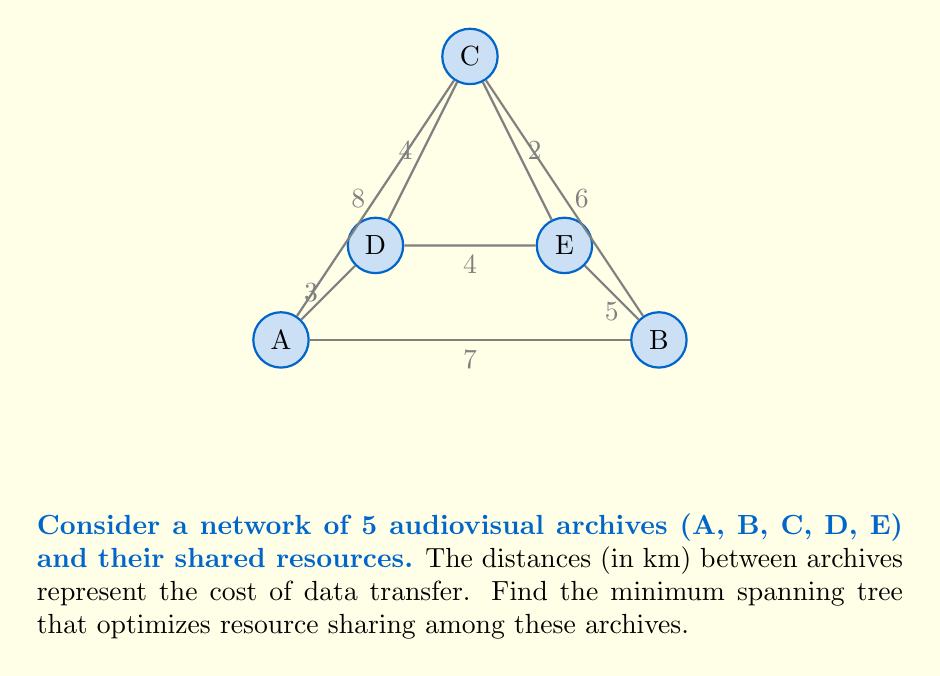Solve this math problem. To find the minimum spanning tree, we'll use Kruskal's algorithm:

1) Sort all edges by weight (distance) in ascending order:
   CE (2), AD (3), CD (4), DE (4), BE (5), BC (6), AB (7), AC (8)

2) Start with an empty graph and add edges, skipping those that would create a cycle:

   - Add CE (2)
   - Add AD (3)
   - Add CD (4) [DE (4) would create a cycle, so skip]
   - Add BE (5)

3) We now have 4 edges connecting 5 vertices, so the minimum spanning tree is complete.

The resulting minimum spanning tree has a total weight of:
$$2 + 3 + 4 + 5 = 14$$

This represents the optimal network for resource sharing among the archives, minimizing the total cost of data transfer.
Answer: Minimum spanning tree: CE, AD, CD, BE; Total weight: 14 km 